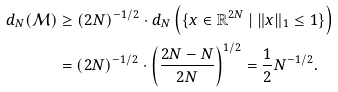Convert formula to latex. <formula><loc_0><loc_0><loc_500><loc_500>d _ { N } ( \mathcal { M } ) & \geq ( 2 N ) ^ { - 1 / 2 } \cdot d _ { N } \left ( \{ x \in \mathbb { R } ^ { 2 N } \ | \ \| x \| _ { 1 } \leq 1 \} \right ) \\ & = ( 2 N ) ^ { - 1 / 2 } \cdot \left ( \frac { 2 N - N } { 2 N } \right ) ^ { 1 / 2 } = \frac { 1 } { 2 } N ^ { - 1 / 2 } .</formula> 